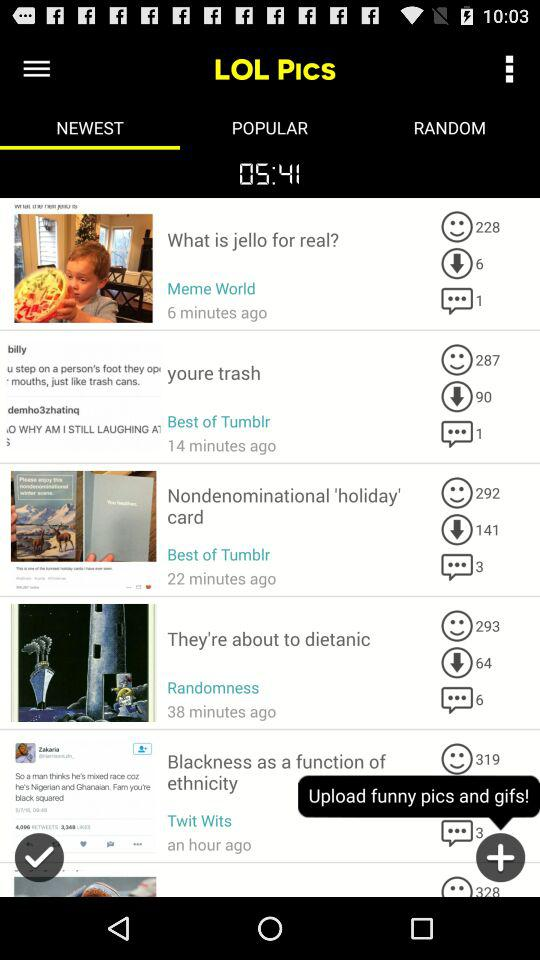Which post received 6 comments? The post is "They're about to dietanic". 